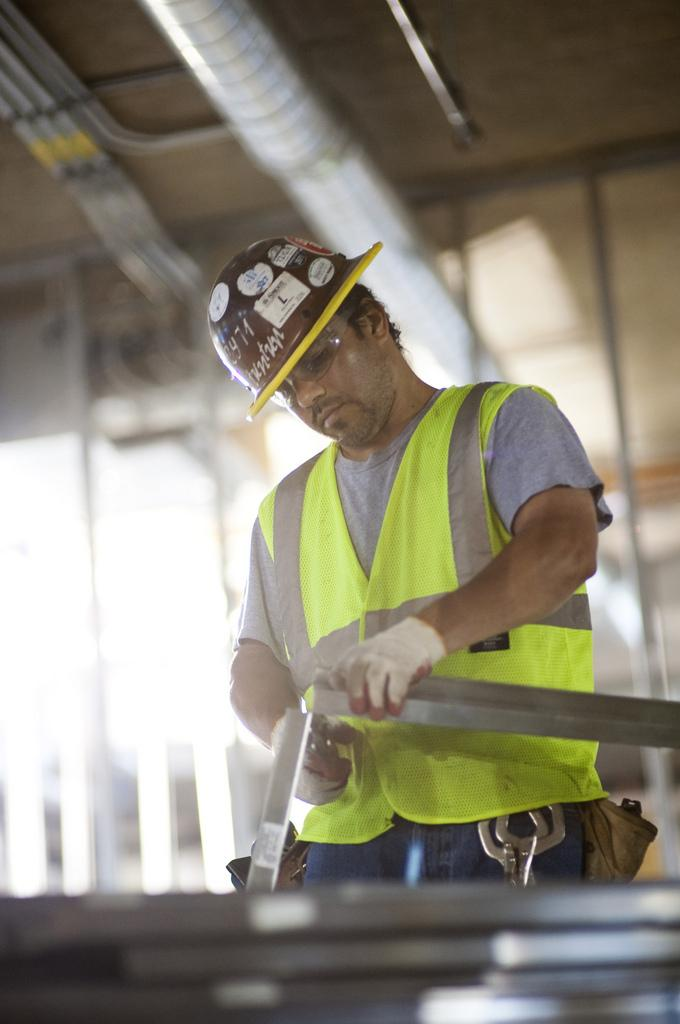What is the main subject of the image? There is a man in the image. What activity is the man engaged in? The man is doing welding work. Can you describe the background of the image? The background of the image is blurred. What type of government is depicted in the image? There is no depiction of a government in the image; it features a man doing welding work. What is the man using to hold the welding beam in the image? There is no beam present in the image; the man is doing welding work, but the specific tool or equipment used is not visible. 